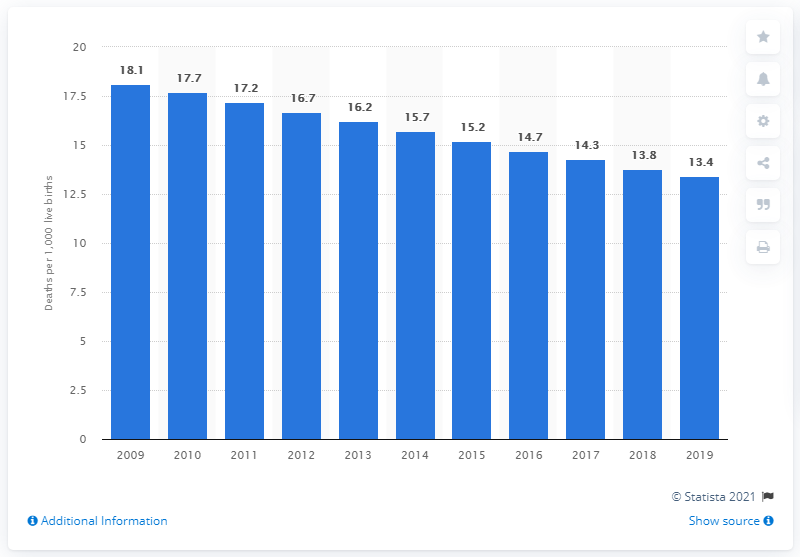Mention a couple of crucial points in this snapshot. In 2019, the infant mortality rate in St. Vincent and the Grenadines was 13.4. 